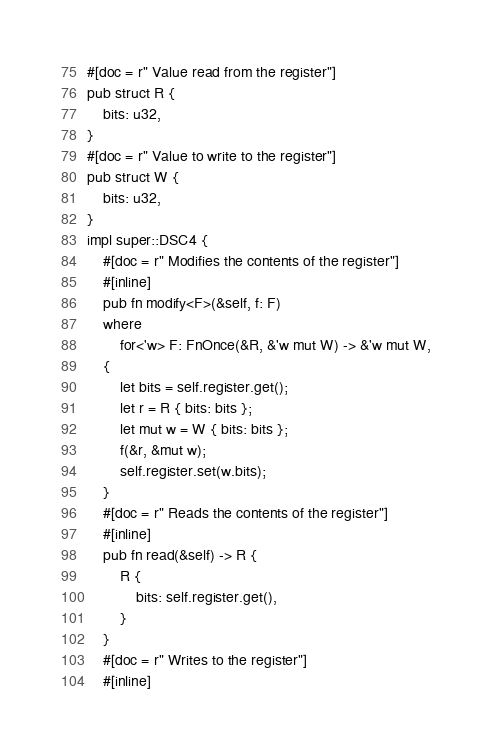<code> <loc_0><loc_0><loc_500><loc_500><_Rust_>#[doc = r" Value read from the register"]
pub struct R {
    bits: u32,
}
#[doc = r" Value to write to the register"]
pub struct W {
    bits: u32,
}
impl super::DSC4 {
    #[doc = r" Modifies the contents of the register"]
    #[inline]
    pub fn modify<F>(&self, f: F)
    where
        for<'w> F: FnOnce(&R, &'w mut W) -> &'w mut W,
    {
        let bits = self.register.get();
        let r = R { bits: bits };
        let mut w = W { bits: bits };
        f(&r, &mut w);
        self.register.set(w.bits);
    }
    #[doc = r" Reads the contents of the register"]
    #[inline]
    pub fn read(&self) -> R {
        R {
            bits: self.register.get(),
        }
    }
    #[doc = r" Writes to the register"]
    #[inline]</code> 